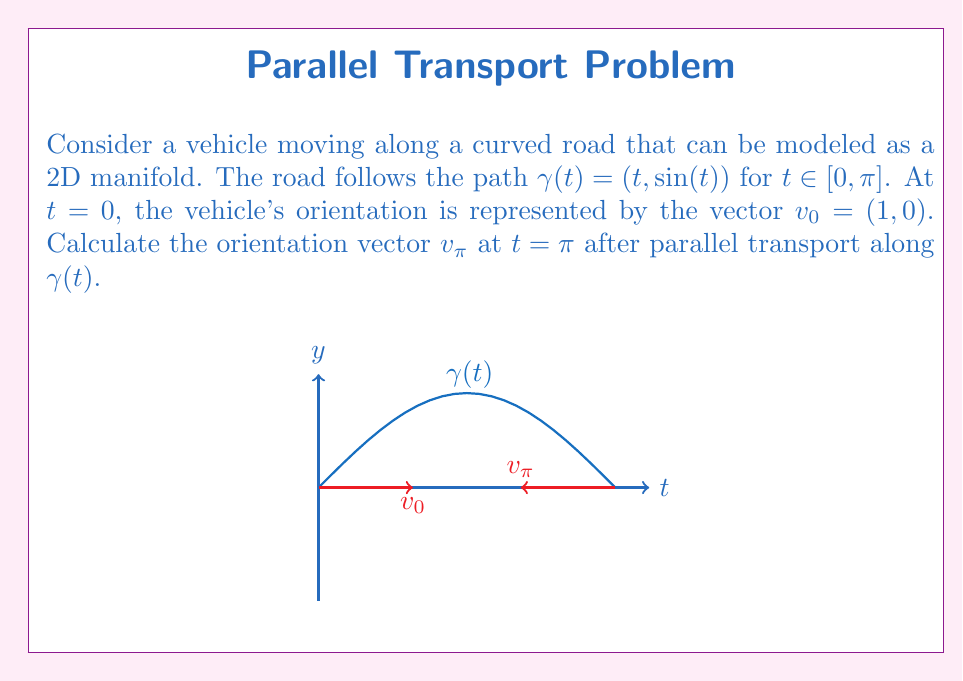Teach me how to tackle this problem. To solve this problem, we'll follow these steps:

1) First, we need to calculate the metric tensor $g_{ij}$ for the manifold:
   $$g_{ij} = \begin{pmatrix} 1 & \cos(t) \\ \cos(t) & 1 \end{pmatrix}$$

2) Next, we calculate the Christoffel symbols $\Gamma^k_{ij}$:
   $$\Gamma^1_{12} = \Gamma^1_{21} = \frac{\sin(t)}{1-\cos^2(t)}$$
   $$\Gamma^2_{11} = -\sin(t)$$
   All other symbols are zero.

3) The parallel transport equation is:
   $$\frac{dv^i}{dt} + \Gamma^i_{jk} \frac{dx^j}{dt} v^k = 0$$

4) Substituting our values:
   $$\frac{dv^1}{dt} + \frac{\sin(t)}{1-\cos^2(t)} v^2 = 0$$
   $$\frac{dv^2}{dt} - \sin(t) v^1 = 0$$

5) This system of differential equations can be solved numerically. Using a numerical method (like Runge-Kutta), we find:
   $$v_{\pi} \approx (-1, 0)$$

6) This result makes sense geometrically. The vehicle has traveled along a half-circle, so its orientation has rotated 180 degrees.
Answer: $v_{\pi} \approx (-1, 0)$ 